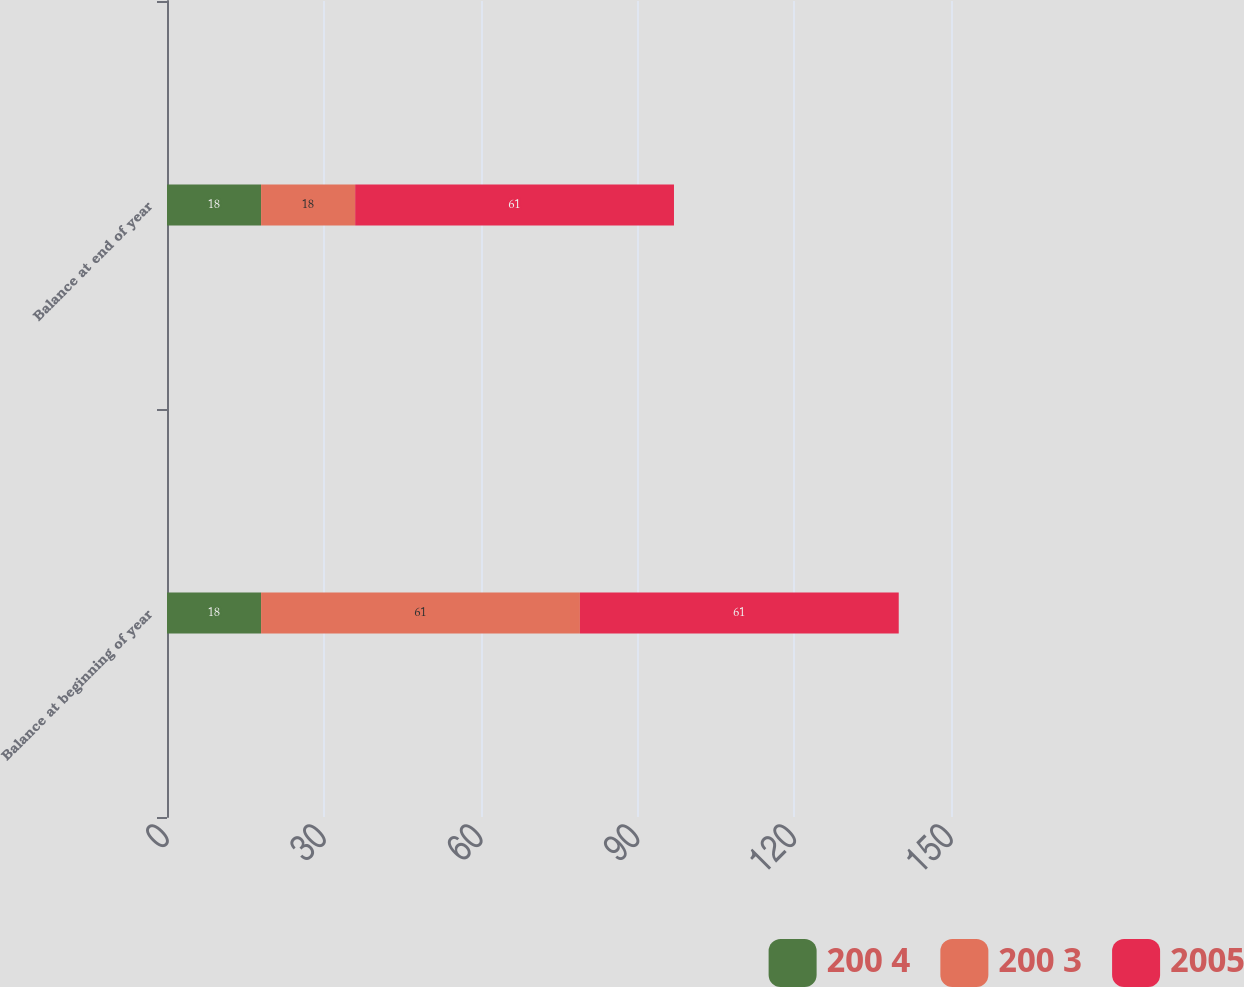<chart> <loc_0><loc_0><loc_500><loc_500><stacked_bar_chart><ecel><fcel>Balance at beginning of year<fcel>Balance at end of year<nl><fcel>200 4<fcel>18<fcel>18<nl><fcel>200 3<fcel>61<fcel>18<nl><fcel>2005<fcel>61<fcel>61<nl></chart> 